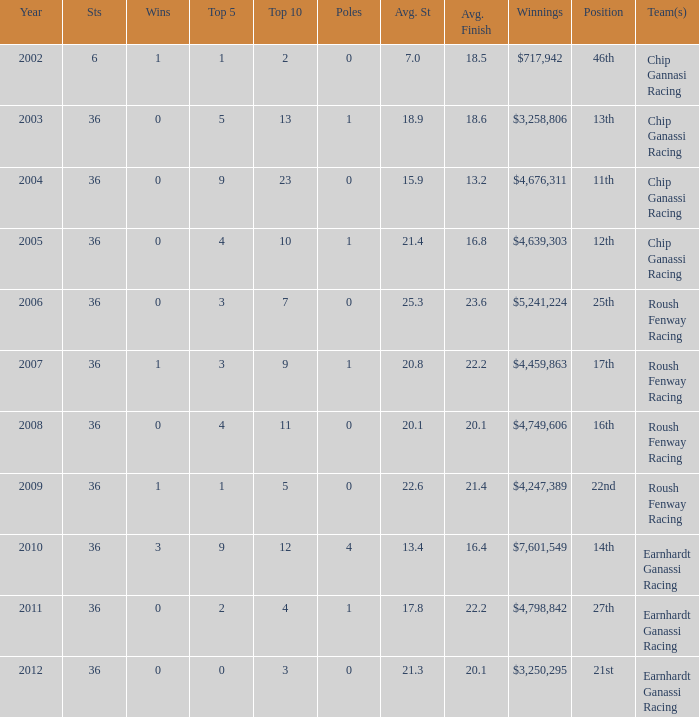Name the poles for 25th position 0.0. 